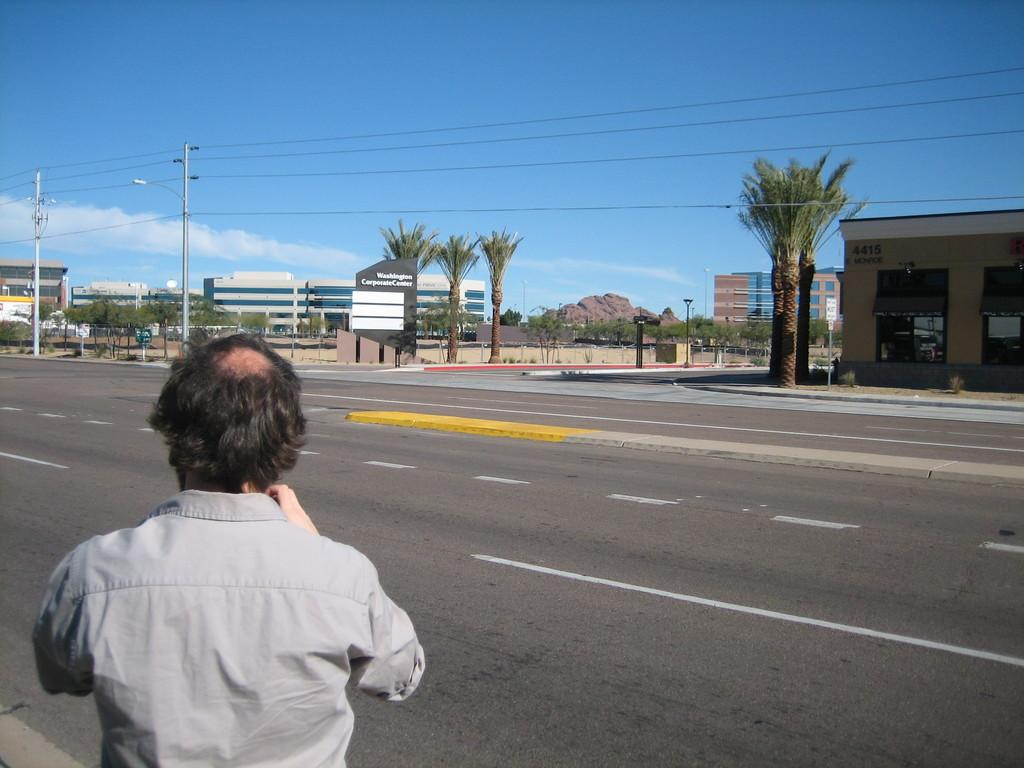Who is present in the image? There is a man in the image. What can be seen in the background of the image? The sky is visible in the background of the image, and there are clouds in the sky. What type of infrastructure is present in the image? There are roads, buildings, poles, lights, boards, and wires in the image. What type of vegetation is present in the image? There are trees in the image. How many members of the flock are visible in the image? There is no flock present in the image; it features a man, roads, trees, buildings, poles, lights, boards, and wires. What type of sink is visible in the image? There is no sink present in the image. 